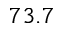Convert formula to latex. <formula><loc_0><loc_0><loc_500><loc_500>7 3 . 7</formula> 